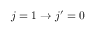<formula> <loc_0><loc_0><loc_500><loc_500>j = 1 \rightarrow j ^ { \prime } = 0</formula> 